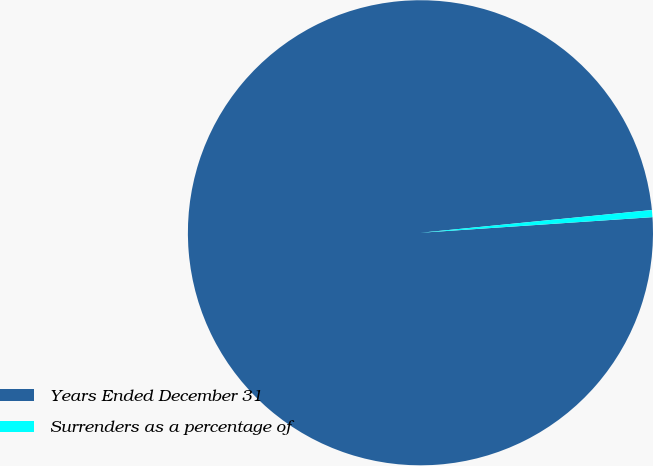Convert chart to OTSL. <chart><loc_0><loc_0><loc_500><loc_500><pie_chart><fcel>Years Ended December 31<fcel>Surrenders as a percentage of<nl><fcel>99.51%<fcel>0.49%<nl></chart> 